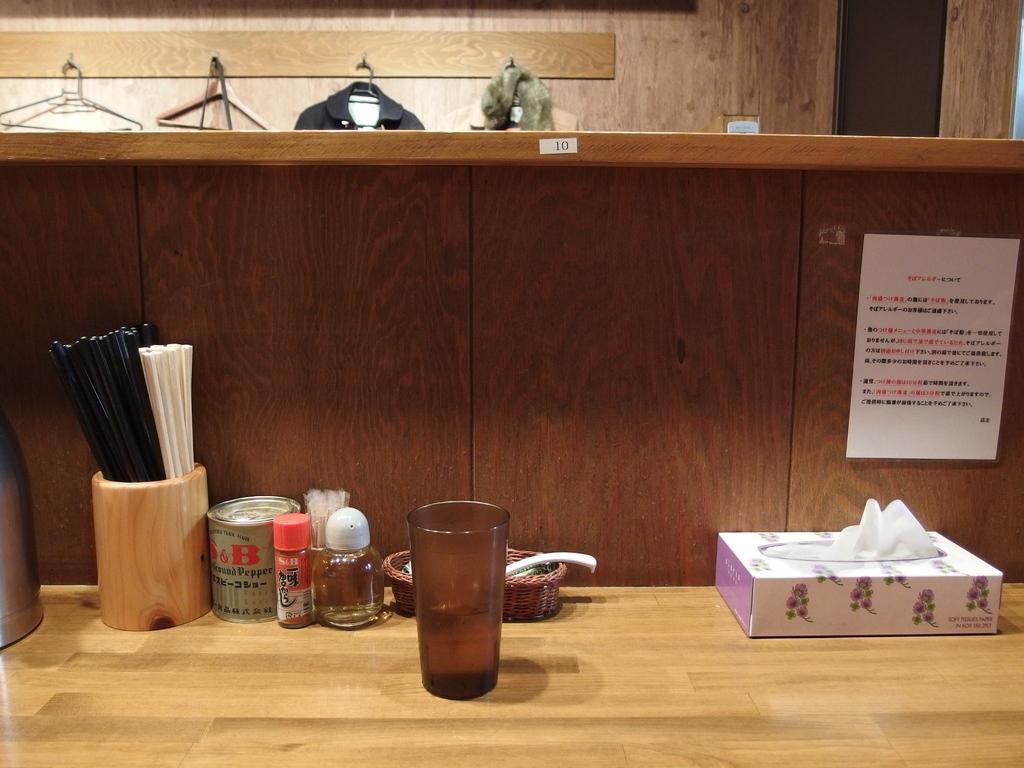Could you give a brief overview of what you see in this image? In this picture we can see a glass, box, and a bottle on the table. And this is poster. 